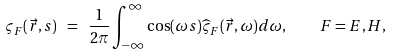<formula> <loc_0><loc_0><loc_500><loc_500>\varsigma _ { F } ( \vec { r } , s ) \ = \ \frac { 1 } { 2 \pi } \int _ { - \infty } ^ { \infty } \cos ( \omega s ) \widehat { \varsigma } _ { F } ( \vec { r } , \omega ) d \omega , \quad F = E , H ,</formula> 